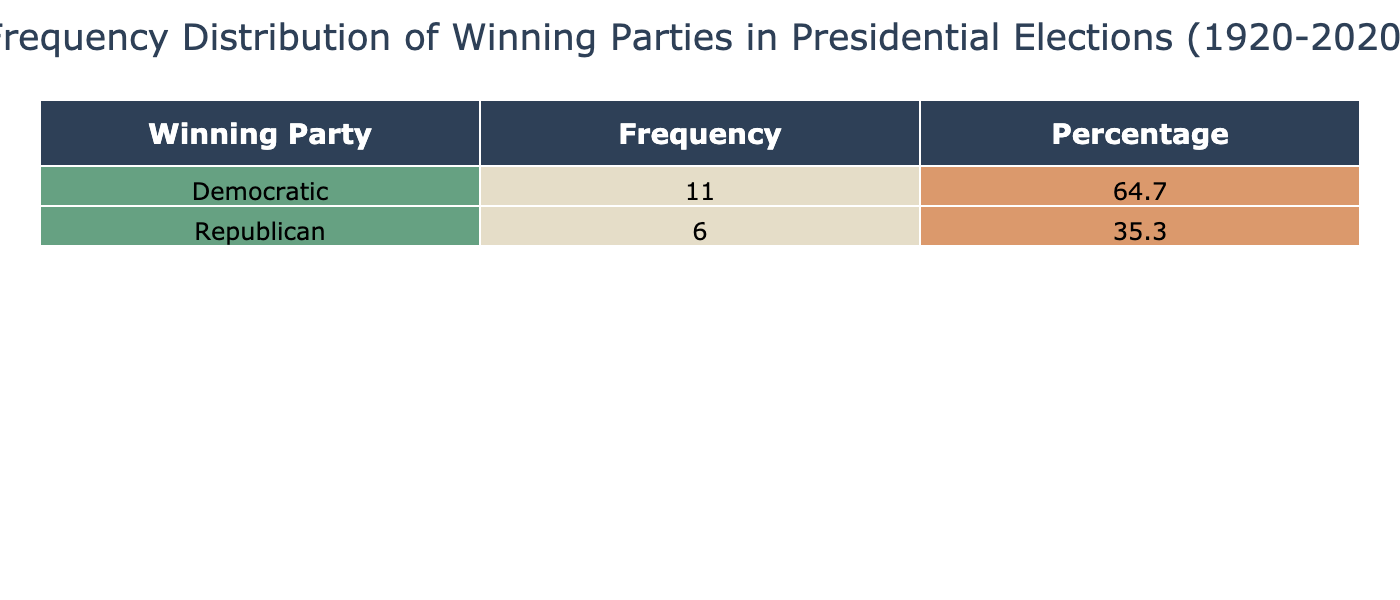What is the most frequent winning party in presidential elections over the past century? The table shows the frequency of each winning party. Counting the frequencies, the Democratic Party won 8 times while the Republican Party won 6 times. Therefore, the most frequent winning party is the Democratic Party with 8 wins.
Answer: Democratic Party How many times did the Republican Party win in presidential elections from 1920 to 2020? The table lists the winning parties and their frequencies. By counting the occurrences of the Republican Party, we find it won 6 times.
Answer: 6 What percentage of the total elections did the Democratic Party win? To find the percentage, we divide the Democratic wins (8) by the total number of elections (14) and multiply by 100. (8/14) * 100 = 57.1, hence the Democratic Party won approximately 57.1% of the elections.
Answer: 57.1 Is it true that the Republican Party won more than 50% of the elections in the 20th century? Counting the Republican wins, it achieved victory 6 times out of the total 14 elections. 6 wins do not constitute more than 50% (7 would be needed), thus it is false that the Republican Party won more than 50% in this timeframe.
Answer: No What is the difference in electoral votes between the highest winning party and the lowest winning party? The highest electoral votes won by the Democratic Party was 523 (Roosevelt in 1936) and the lowest was 84 (Roosevelt in 1940). The difference is 523 - 84 = 439. Therefore, the difference in electoral votes is 439.
Answer: 439 How many elections had a winning party that secured less than 50% of the popular votes? By examining the popular vote percentages for each election, we identify that Richard Nixon in 1968 (43.4%), Bill Clinton in 1992 (43.0%), and Donald Trump in 2016 (46.2%) are below 50%. Thus, there were 3 such elections.
Answer: 3 What is the average percentage of popular votes obtained by winning candidates in this data set? The average can be calculated by summing the popular vote percentages of all winning candidates (60.3, 57.4, 60.8, 54.7, 53.4, 49.7, 61.1, 50.1, 50.5, 58.8, 43.0, 49.2, 47.9, 52.9, 46.2, 51.3) and dividing by the number of elections. The total is 801.7 and dividing by 14 gives an average of 57.3%.
Answer: 57.3 How many Democratic candidates won with at least 60% of the popular vote? From the table, we see that Franklin D. Roosevelt in 1936 (60.8%) and Lyndon B. Johnson in 1964 (61.1%) won with more than 60% of the popular vote. Thus, there are 2 such candidates.
Answer: 2 What winning party had the highest electoral vote count, and how many electoral votes did it receive? By checking each electoral vote count in the table, the highest is 523 votes, which was achieved by Franklin D. Roosevelt of the Democratic Party in 1936. Thus, the winning party with the highest electoral vote count is the Democratic Party with 523 electoral votes.
Answer: Democratic Party, 523 